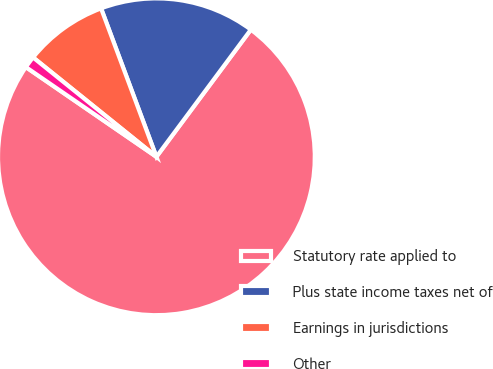Convert chart. <chart><loc_0><loc_0><loc_500><loc_500><pie_chart><fcel>Statutory rate applied to<fcel>Plus state income taxes net of<fcel>Earnings in jurisdictions<fcel>Other<nl><fcel>74.42%<fcel>15.85%<fcel>8.53%<fcel>1.21%<nl></chart> 